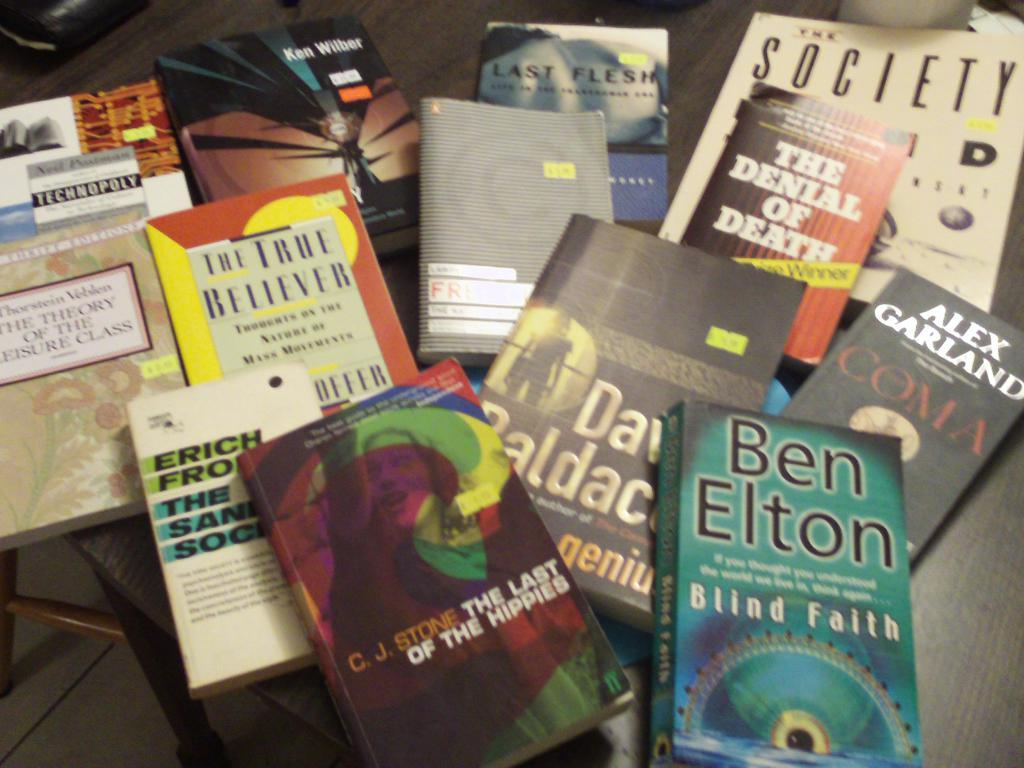<image>
Write a terse but informative summary of the picture. Several books on a table one is called The denial of death. 